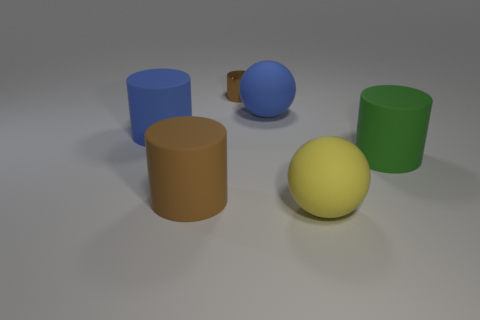Subtract all gray cylinders. Subtract all red balls. How many cylinders are left? 4 Add 3 small yellow shiny objects. How many objects exist? 9 Subtract all cylinders. How many objects are left? 2 Add 2 yellow blocks. How many yellow blocks exist? 2 Subtract 0 purple balls. How many objects are left? 6 Subtract all large green cylinders. Subtract all big green things. How many objects are left? 4 Add 2 small metallic cylinders. How many small metallic cylinders are left? 3 